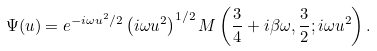<formula> <loc_0><loc_0><loc_500><loc_500>\Psi ( u ) = e ^ { - i \omega u ^ { 2 } / 2 } \left ( i \omega u ^ { 2 } \right ) ^ { 1 / 2 } M \left ( \frac { 3 } { 4 } + i \beta \omega , \frac { 3 } { 2 } ; i \omega u ^ { 2 } \right ) .</formula> 